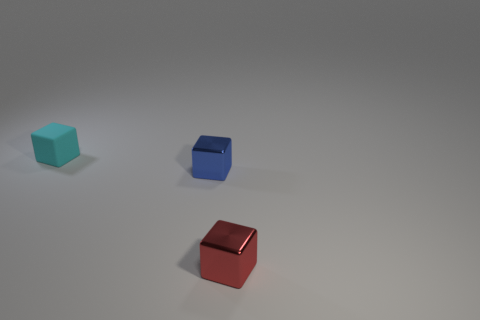What textures are visible on the surfaces of the objects? The objects in the image display a distinct matte finish with very subtle light reflections, indicating a relatively smooth but not glossy texture. 